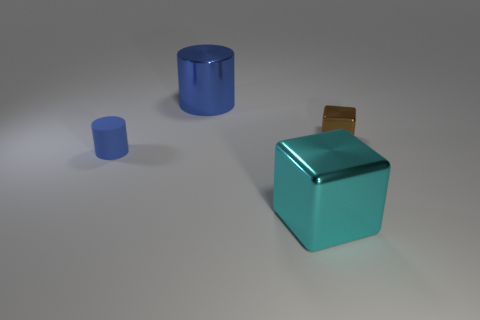Add 4 cyan blocks. How many objects exist? 8 Add 4 yellow metallic blocks. How many yellow metallic blocks exist? 4 Subtract 0 yellow balls. How many objects are left? 4 Subtract all big metal cubes. Subtract all big yellow rubber cylinders. How many objects are left? 3 Add 2 small brown metal blocks. How many small brown metal blocks are left? 3 